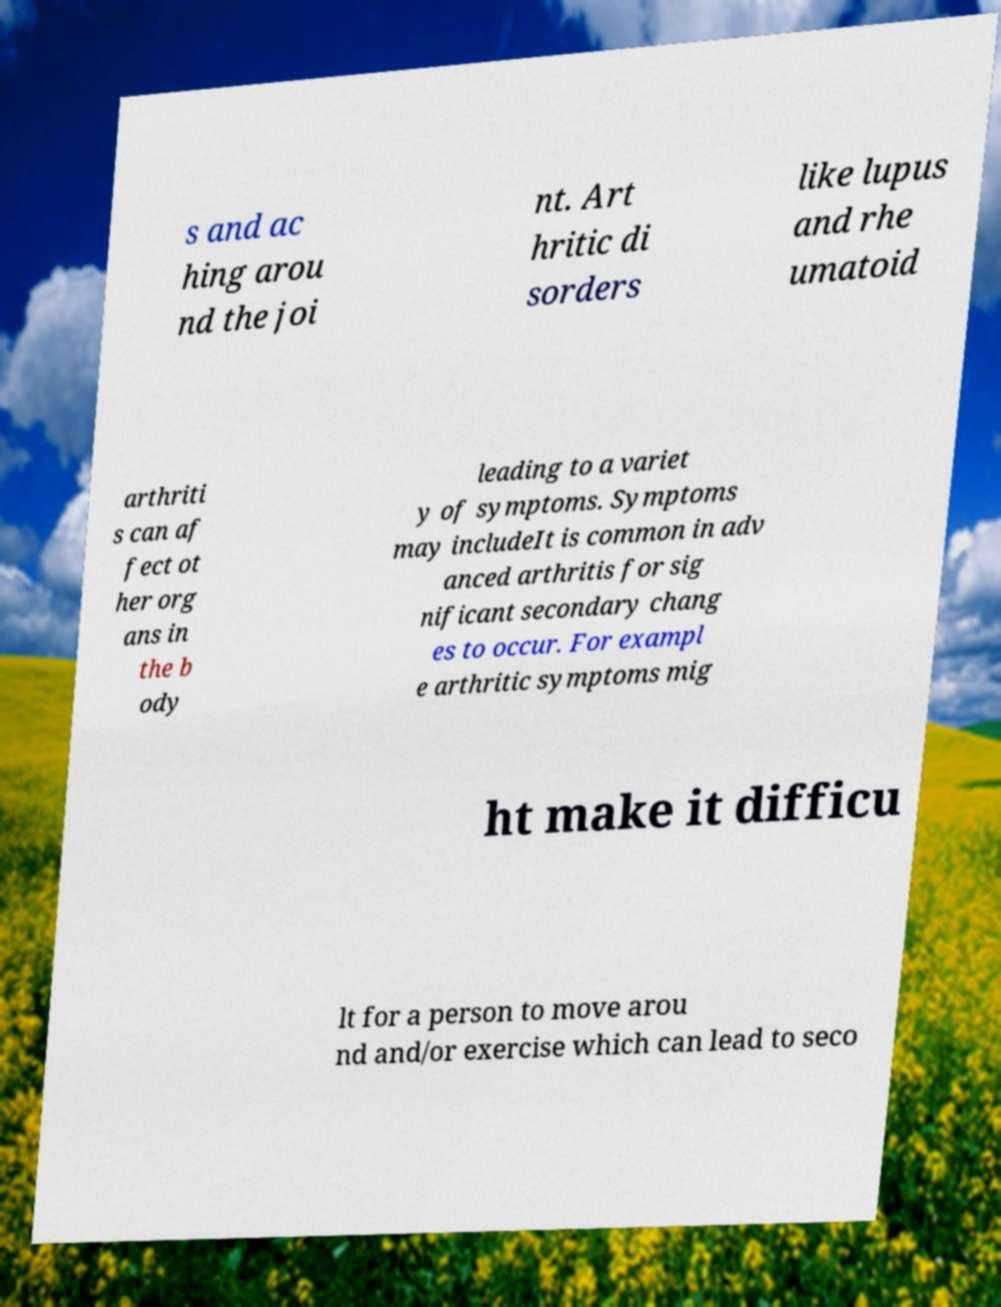Please identify and transcribe the text found in this image. s and ac hing arou nd the joi nt. Art hritic di sorders like lupus and rhe umatoid arthriti s can af fect ot her org ans in the b ody leading to a variet y of symptoms. Symptoms may includeIt is common in adv anced arthritis for sig nificant secondary chang es to occur. For exampl e arthritic symptoms mig ht make it difficu lt for a person to move arou nd and/or exercise which can lead to seco 